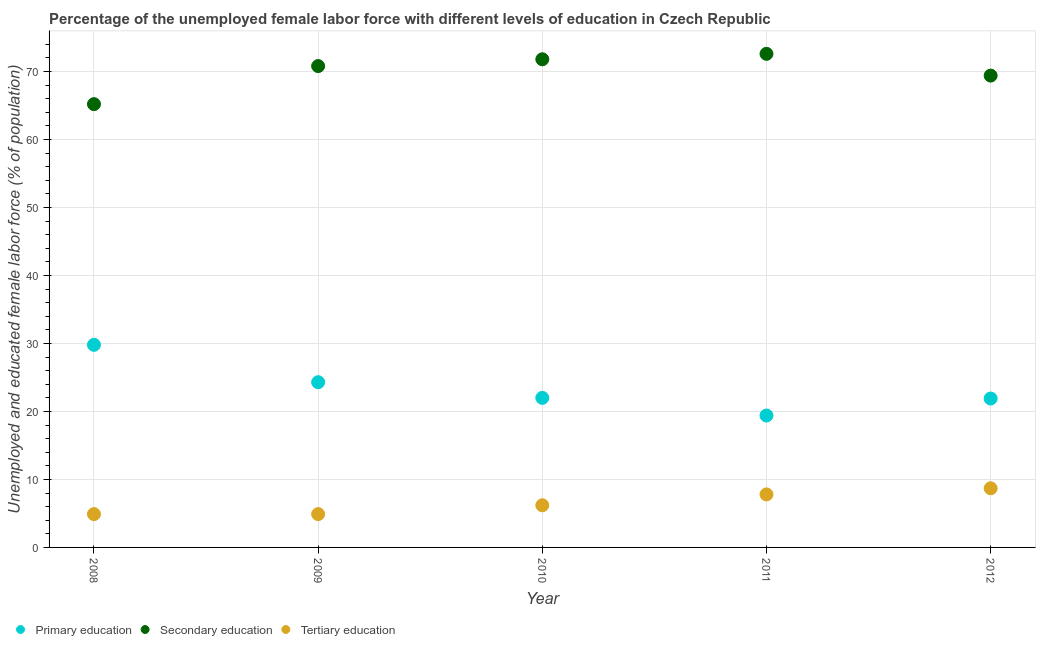What is the percentage of female labor force who received primary education in 2012?
Provide a short and direct response. 21.9. Across all years, what is the maximum percentage of female labor force who received tertiary education?
Offer a very short reply. 8.7. Across all years, what is the minimum percentage of female labor force who received tertiary education?
Provide a succinct answer. 4.9. In which year was the percentage of female labor force who received secondary education maximum?
Ensure brevity in your answer.  2011. What is the total percentage of female labor force who received tertiary education in the graph?
Offer a terse response. 32.5. What is the difference between the percentage of female labor force who received primary education in 2010 and that in 2012?
Give a very brief answer. 0.1. What is the difference between the percentage of female labor force who received tertiary education in 2010 and the percentage of female labor force who received primary education in 2012?
Keep it short and to the point. -15.7. What is the average percentage of female labor force who received tertiary education per year?
Provide a succinct answer. 6.5. In the year 2012, what is the difference between the percentage of female labor force who received primary education and percentage of female labor force who received tertiary education?
Ensure brevity in your answer.  13.2. In how many years, is the percentage of female labor force who received primary education greater than 52 %?
Your answer should be compact. 0. What is the ratio of the percentage of female labor force who received secondary education in 2008 to that in 2012?
Offer a terse response. 0.94. Is the percentage of female labor force who received secondary education in 2008 less than that in 2012?
Offer a very short reply. Yes. What is the difference between the highest and the lowest percentage of female labor force who received tertiary education?
Offer a terse response. 3.8. Does the percentage of female labor force who received tertiary education monotonically increase over the years?
Your answer should be very brief. No. Is the percentage of female labor force who received secondary education strictly greater than the percentage of female labor force who received primary education over the years?
Offer a terse response. Yes. Is the percentage of female labor force who received secondary education strictly less than the percentage of female labor force who received primary education over the years?
Your answer should be compact. No. How many dotlines are there?
Your response must be concise. 3. What is the difference between two consecutive major ticks on the Y-axis?
Provide a short and direct response. 10. Are the values on the major ticks of Y-axis written in scientific E-notation?
Give a very brief answer. No. Does the graph contain any zero values?
Make the answer very short. No. How are the legend labels stacked?
Offer a terse response. Horizontal. What is the title of the graph?
Give a very brief answer. Percentage of the unemployed female labor force with different levels of education in Czech Republic. Does "Ages 60+" appear as one of the legend labels in the graph?
Your response must be concise. No. What is the label or title of the Y-axis?
Ensure brevity in your answer.  Unemployed and educated female labor force (% of population). What is the Unemployed and educated female labor force (% of population) of Primary education in 2008?
Offer a very short reply. 29.8. What is the Unemployed and educated female labor force (% of population) of Secondary education in 2008?
Your response must be concise. 65.2. What is the Unemployed and educated female labor force (% of population) of Tertiary education in 2008?
Make the answer very short. 4.9. What is the Unemployed and educated female labor force (% of population) of Primary education in 2009?
Keep it short and to the point. 24.3. What is the Unemployed and educated female labor force (% of population) in Secondary education in 2009?
Provide a short and direct response. 70.8. What is the Unemployed and educated female labor force (% of population) of Tertiary education in 2009?
Offer a terse response. 4.9. What is the Unemployed and educated female labor force (% of population) in Primary education in 2010?
Your answer should be compact. 22. What is the Unemployed and educated female labor force (% of population) in Secondary education in 2010?
Provide a succinct answer. 71.8. What is the Unemployed and educated female labor force (% of population) of Tertiary education in 2010?
Make the answer very short. 6.2. What is the Unemployed and educated female labor force (% of population) of Primary education in 2011?
Your response must be concise. 19.4. What is the Unemployed and educated female labor force (% of population) in Secondary education in 2011?
Your response must be concise. 72.6. What is the Unemployed and educated female labor force (% of population) in Tertiary education in 2011?
Your response must be concise. 7.8. What is the Unemployed and educated female labor force (% of population) of Primary education in 2012?
Offer a terse response. 21.9. What is the Unemployed and educated female labor force (% of population) of Secondary education in 2012?
Provide a short and direct response. 69.4. What is the Unemployed and educated female labor force (% of population) in Tertiary education in 2012?
Give a very brief answer. 8.7. Across all years, what is the maximum Unemployed and educated female labor force (% of population) in Primary education?
Offer a very short reply. 29.8. Across all years, what is the maximum Unemployed and educated female labor force (% of population) in Secondary education?
Provide a short and direct response. 72.6. Across all years, what is the maximum Unemployed and educated female labor force (% of population) of Tertiary education?
Offer a terse response. 8.7. Across all years, what is the minimum Unemployed and educated female labor force (% of population) in Primary education?
Provide a short and direct response. 19.4. Across all years, what is the minimum Unemployed and educated female labor force (% of population) of Secondary education?
Your answer should be compact. 65.2. Across all years, what is the minimum Unemployed and educated female labor force (% of population) in Tertiary education?
Give a very brief answer. 4.9. What is the total Unemployed and educated female labor force (% of population) in Primary education in the graph?
Offer a terse response. 117.4. What is the total Unemployed and educated female labor force (% of population) in Secondary education in the graph?
Provide a short and direct response. 349.8. What is the total Unemployed and educated female labor force (% of population) in Tertiary education in the graph?
Offer a very short reply. 32.5. What is the difference between the Unemployed and educated female labor force (% of population) in Secondary education in 2008 and that in 2009?
Your answer should be compact. -5.6. What is the difference between the Unemployed and educated female labor force (% of population) in Primary education in 2008 and that in 2010?
Give a very brief answer. 7.8. What is the difference between the Unemployed and educated female labor force (% of population) in Secondary education in 2008 and that in 2010?
Offer a very short reply. -6.6. What is the difference between the Unemployed and educated female labor force (% of population) in Tertiary education in 2008 and that in 2010?
Offer a terse response. -1.3. What is the difference between the Unemployed and educated female labor force (% of population) in Secondary education in 2008 and that in 2011?
Ensure brevity in your answer.  -7.4. What is the difference between the Unemployed and educated female labor force (% of population) of Tertiary education in 2008 and that in 2011?
Ensure brevity in your answer.  -2.9. What is the difference between the Unemployed and educated female labor force (% of population) in Primary education in 2008 and that in 2012?
Your answer should be compact. 7.9. What is the difference between the Unemployed and educated female labor force (% of population) in Secondary education in 2008 and that in 2012?
Offer a very short reply. -4.2. What is the difference between the Unemployed and educated female labor force (% of population) of Tertiary education in 2009 and that in 2010?
Your answer should be compact. -1.3. What is the difference between the Unemployed and educated female labor force (% of population) of Secondary education in 2009 and that in 2011?
Make the answer very short. -1.8. What is the difference between the Unemployed and educated female labor force (% of population) of Tertiary education in 2009 and that in 2011?
Offer a terse response. -2.9. What is the difference between the Unemployed and educated female labor force (% of population) of Primary education in 2009 and that in 2012?
Ensure brevity in your answer.  2.4. What is the difference between the Unemployed and educated female labor force (% of population) in Secondary education in 2009 and that in 2012?
Keep it short and to the point. 1.4. What is the difference between the Unemployed and educated female labor force (% of population) of Tertiary education in 2009 and that in 2012?
Your answer should be compact. -3.8. What is the difference between the Unemployed and educated female labor force (% of population) of Primary education in 2010 and that in 2011?
Your answer should be very brief. 2.6. What is the difference between the Unemployed and educated female labor force (% of population) of Secondary education in 2010 and that in 2011?
Make the answer very short. -0.8. What is the difference between the Unemployed and educated female labor force (% of population) in Primary education in 2010 and that in 2012?
Give a very brief answer. 0.1. What is the difference between the Unemployed and educated female labor force (% of population) of Primary education in 2008 and the Unemployed and educated female labor force (% of population) of Secondary education in 2009?
Offer a very short reply. -41. What is the difference between the Unemployed and educated female labor force (% of population) of Primary education in 2008 and the Unemployed and educated female labor force (% of population) of Tertiary education in 2009?
Offer a very short reply. 24.9. What is the difference between the Unemployed and educated female labor force (% of population) of Secondary education in 2008 and the Unemployed and educated female labor force (% of population) of Tertiary education in 2009?
Your answer should be very brief. 60.3. What is the difference between the Unemployed and educated female labor force (% of population) of Primary education in 2008 and the Unemployed and educated female labor force (% of population) of Secondary education in 2010?
Offer a very short reply. -42. What is the difference between the Unemployed and educated female labor force (% of population) of Primary education in 2008 and the Unemployed and educated female labor force (% of population) of Tertiary education in 2010?
Keep it short and to the point. 23.6. What is the difference between the Unemployed and educated female labor force (% of population) of Secondary education in 2008 and the Unemployed and educated female labor force (% of population) of Tertiary education in 2010?
Ensure brevity in your answer.  59. What is the difference between the Unemployed and educated female labor force (% of population) in Primary education in 2008 and the Unemployed and educated female labor force (% of population) in Secondary education in 2011?
Provide a succinct answer. -42.8. What is the difference between the Unemployed and educated female labor force (% of population) in Primary education in 2008 and the Unemployed and educated female labor force (% of population) in Tertiary education in 2011?
Your answer should be compact. 22. What is the difference between the Unemployed and educated female labor force (% of population) of Secondary education in 2008 and the Unemployed and educated female labor force (% of population) of Tertiary education in 2011?
Your answer should be compact. 57.4. What is the difference between the Unemployed and educated female labor force (% of population) in Primary education in 2008 and the Unemployed and educated female labor force (% of population) in Secondary education in 2012?
Keep it short and to the point. -39.6. What is the difference between the Unemployed and educated female labor force (% of population) in Primary education in 2008 and the Unemployed and educated female labor force (% of population) in Tertiary education in 2012?
Your answer should be very brief. 21.1. What is the difference between the Unemployed and educated female labor force (% of population) of Secondary education in 2008 and the Unemployed and educated female labor force (% of population) of Tertiary education in 2012?
Make the answer very short. 56.5. What is the difference between the Unemployed and educated female labor force (% of population) in Primary education in 2009 and the Unemployed and educated female labor force (% of population) in Secondary education in 2010?
Offer a terse response. -47.5. What is the difference between the Unemployed and educated female labor force (% of population) of Primary education in 2009 and the Unemployed and educated female labor force (% of population) of Tertiary education in 2010?
Offer a very short reply. 18.1. What is the difference between the Unemployed and educated female labor force (% of population) in Secondary education in 2009 and the Unemployed and educated female labor force (% of population) in Tertiary education in 2010?
Provide a short and direct response. 64.6. What is the difference between the Unemployed and educated female labor force (% of population) in Primary education in 2009 and the Unemployed and educated female labor force (% of population) in Secondary education in 2011?
Ensure brevity in your answer.  -48.3. What is the difference between the Unemployed and educated female labor force (% of population) of Primary education in 2009 and the Unemployed and educated female labor force (% of population) of Tertiary education in 2011?
Provide a short and direct response. 16.5. What is the difference between the Unemployed and educated female labor force (% of population) in Primary education in 2009 and the Unemployed and educated female labor force (% of population) in Secondary education in 2012?
Offer a very short reply. -45.1. What is the difference between the Unemployed and educated female labor force (% of population) of Secondary education in 2009 and the Unemployed and educated female labor force (% of population) of Tertiary education in 2012?
Provide a short and direct response. 62.1. What is the difference between the Unemployed and educated female labor force (% of population) of Primary education in 2010 and the Unemployed and educated female labor force (% of population) of Secondary education in 2011?
Provide a succinct answer. -50.6. What is the difference between the Unemployed and educated female labor force (% of population) of Secondary education in 2010 and the Unemployed and educated female labor force (% of population) of Tertiary education in 2011?
Your answer should be very brief. 64. What is the difference between the Unemployed and educated female labor force (% of population) of Primary education in 2010 and the Unemployed and educated female labor force (% of population) of Secondary education in 2012?
Provide a short and direct response. -47.4. What is the difference between the Unemployed and educated female labor force (% of population) in Primary education in 2010 and the Unemployed and educated female labor force (% of population) in Tertiary education in 2012?
Offer a terse response. 13.3. What is the difference between the Unemployed and educated female labor force (% of population) in Secondary education in 2010 and the Unemployed and educated female labor force (% of population) in Tertiary education in 2012?
Offer a very short reply. 63.1. What is the difference between the Unemployed and educated female labor force (% of population) of Secondary education in 2011 and the Unemployed and educated female labor force (% of population) of Tertiary education in 2012?
Keep it short and to the point. 63.9. What is the average Unemployed and educated female labor force (% of population) of Primary education per year?
Make the answer very short. 23.48. What is the average Unemployed and educated female labor force (% of population) of Secondary education per year?
Provide a succinct answer. 69.96. In the year 2008, what is the difference between the Unemployed and educated female labor force (% of population) of Primary education and Unemployed and educated female labor force (% of population) of Secondary education?
Provide a succinct answer. -35.4. In the year 2008, what is the difference between the Unemployed and educated female labor force (% of population) of Primary education and Unemployed and educated female labor force (% of population) of Tertiary education?
Offer a very short reply. 24.9. In the year 2008, what is the difference between the Unemployed and educated female labor force (% of population) of Secondary education and Unemployed and educated female labor force (% of population) of Tertiary education?
Ensure brevity in your answer.  60.3. In the year 2009, what is the difference between the Unemployed and educated female labor force (% of population) in Primary education and Unemployed and educated female labor force (% of population) in Secondary education?
Provide a short and direct response. -46.5. In the year 2009, what is the difference between the Unemployed and educated female labor force (% of population) in Secondary education and Unemployed and educated female labor force (% of population) in Tertiary education?
Provide a succinct answer. 65.9. In the year 2010, what is the difference between the Unemployed and educated female labor force (% of population) in Primary education and Unemployed and educated female labor force (% of population) in Secondary education?
Offer a very short reply. -49.8. In the year 2010, what is the difference between the Unemployed and educated female labor force (% of population) in Secondary education and Unemployed and educated female labor force (% of population) in Tertiary education?
Give a very brief answer. 65.6. In the year 2011, what is the difference between the Unemployed and educated female labor force (% of population) of Primary education and Unemployed and educated female labor force (% of population) of Secondary education?
Your answer should be compact. -53.2. In the year 2011, what is the difference between the Unemployed and educated female labor force (% of population) in Secondary education and Unemployed and educated female labor force (% of population) in Tertiary education?
Your answer should be very brief. 64.8. In the year 2012, what is the difference between the Unemployed and educated female labor force (% of population) in Primary education and Unemployed and educated female labor force (% of population) in Secondary education?
Provide a short and direct response. -47.5. In the year 2012, what is the difference between the Unemployed and educated female labor force (% of population) of Primary education and Unemployed and educated female labor force (% of population) of Tertiary education?
Offer a very short reply. 13.2. In the year 2012, what is the difference between the Unemployed and educated female labor force (% of population) of Secondary education and Unemployed and educated female labor force (% of population) of Tertiary education?
Your answer should be very brief. 60.7. What is the ratio of the Unemployed and educated female labor force (% of population) of Primary education in 2008 to that in 2009?
Ensure brevity in your answer.  1.23. What is the ratio of the Unemployed and educated female labor force (% of population) of Secondary education in 2008 to that in 2009?
Your answer should be very brief. 0.92. What is the ratio of the Unemployed and educated female labor force (% of population) of Primary education in 2008 to that in 2010?
Ensure brevity in your answer.  1.35. What is the ratio of the Unemployed and educated female labor force (% of population) of Secondary education in 2008 to that in 2010?
Keep it short and to the point. 0.91. What is the ratio of the Unemployed and educated female labor force (% of population) in Tertiary education in 2008 to that in 2010?
Offer a terse response. 0.79. What is the ratio of the Unemployed and educated female labor force (% of population) in Primary education in 2008 to that in 2011?
Offer a very short reply. 1.54. What is the ratio of the Unemployed and educated female labor force (% of population) in Secondary education in 2008 to that in 2011?
Give a very brief answer. 0.9. What is the ratio of the Unemployed and educated female labor force (% of population) of Tertiary education in 2008 to that in 2011?
Make the answer very short. 0.63. What is the ratio of the Unemployed and educated female labor force (% of population) in Primary education in 2008 to that in 2012?
Give a very brief answer. 1.36. What is the ratio of the Unemployed and educated female labor force (% of population) of Secondary education in 2008 to that in 2012?
Your answer should be compact. 0.94. What is the ratio of the Unemployed and educated female labor force (% of population) in Tertiary education in 2008 to that in 2012?
Offer a very short reply. 0.56. What is the ratio of the Unemployed and educated female labor force (% of population) in Primary education in 2009 to that in 2010?
Keep it short and to the point. 1.1. What is the ratio of the Unemployed and educated female labor force (% of population) in Secondary education in 2009 to that in 2010?
Give a very brief answer. 0.99. What is the ratio of the Unemployed and educated female labor force (% of population) of Tertiary education in 2009 to that in 2010?
Give a very brief answer. 0.79. What is the ratio of the Unemployed and educated female labor force (% of population) of Primary education in 2009 to that in 2011?
Offer a terse response. 1.25. What is the ratio of the Unemployed and educated female labor force (% of population) in Secondary education in 2009 to that in 2011?
Offer a very short reply. 0.98. What is the ratio of the Unemployed and educated female labor force (% of population) of Tertiary education in 2009 to that in 2011?
Make the answer very short. 0.63. What is the ratio of the Unemployed and educated female labor force (% of population) of Primary education in 2009 to that in 2012?
Provide a succinct answer. 1.11. What is the ratio of the Unemployed and educated female labor force (% of population) in Secondary education in 2009 to that in 2012?
Provide a short and direct response. 1.02. What is the ratio of the Unemployed and educated female labor force (% of population) in Tertiary education in 2009 to that in 2012?
Your response must be concise. 0.56. What is the ratio of the Unemployed and educated female labor force (% of population) of Primary education in 2010 to that in 2011?
Provide a succinct answer. 1.13. What is the ratio of the Unemployed and educated female labor force (% of population) of Secondary education in 2010 to that in 2011?
Your answer should be compact. 0.99. What is the ratio of the Unemployed and educated female labor force (% of population) in Tertiary education in 2010 to that in 2011?
Make the answer very short. 0.79. What is the ratio of the Unemployed and educated female labor force (% of population) of Secondary education in 2010 to that in 2012?
Provide a succinct answer. 1.03. What is the ratio of the Unemployed and educated female labor force (% of population) of Tertiary education in 2010 to that in 2012?
Provide a succinct answer. 0.71. What is the ratio of the Unemployed and educated female labor force (% of population) in Primary education in 2011 to that in 2012?
Your answer should be very brief. 0.89. What is the ratio of the Unemployed and educated female labor force (% of population) of Secondary education in 2011 to that in 2012?
Keep it short and to the point. 1.05. What is the ratio of the Unemployed and educated female labor force (% of population) in Tertiary education in 2011 to that in 2012?
Provide a short and direct response. 0.9. What is the difference between the highest and the second highest Unemployed and educated female labor force (% of population) in Primary education?
Make the answer very short. 5.5. What is the difference between the highest and the second highest Unemployed and educated female labor force (% of population) in Secondary education?
Keep it short and to the point. 0.8. What is the difference between the highest and the lowest Unemployed and educated female labor force (% of population) in Primary education?
Make the answer very short. 10.4. What is the difference between the highest and the lowest Unemployed and educated female labor force (% of population) of Secondary education?
Your answer should be very brief. 7.4. 